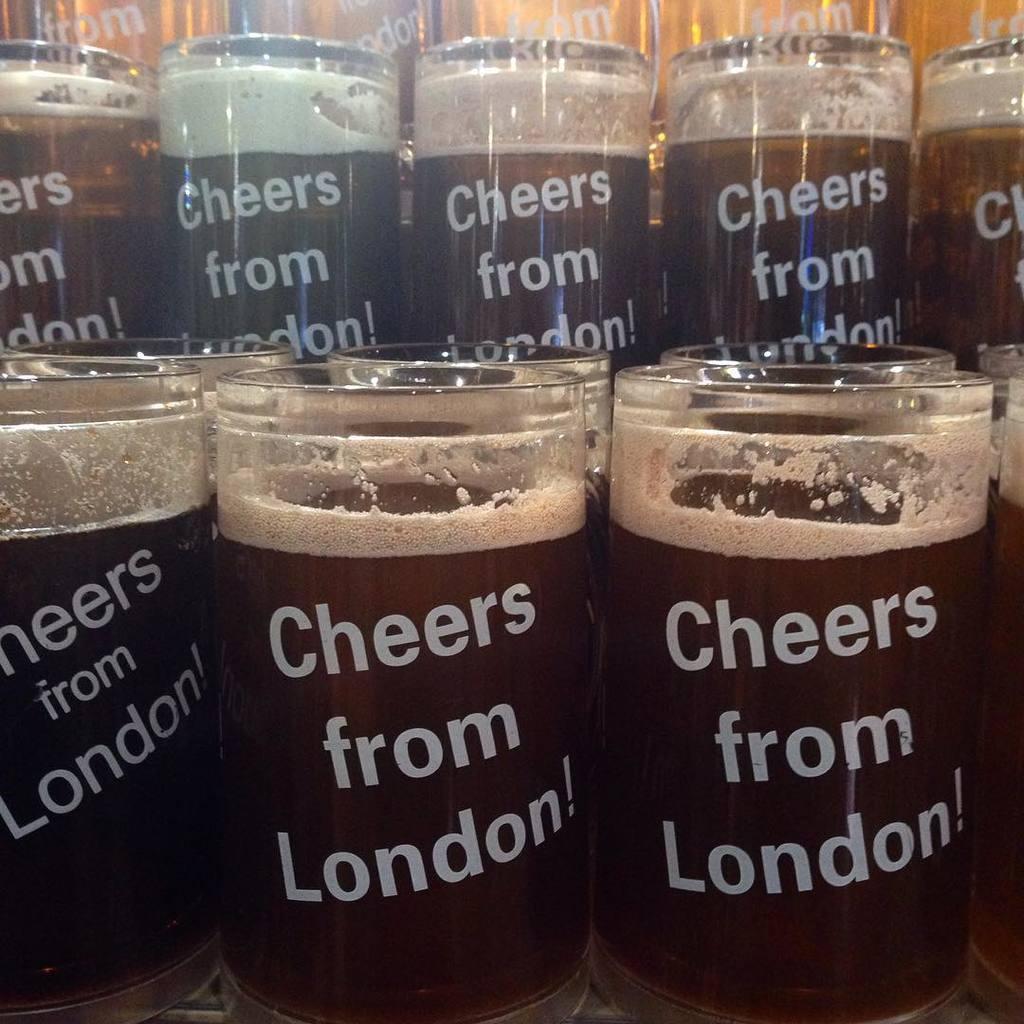Can you describe this image briefly? In this picture we can see many number of glasses containing drinks and we can see the text on the glasses. 